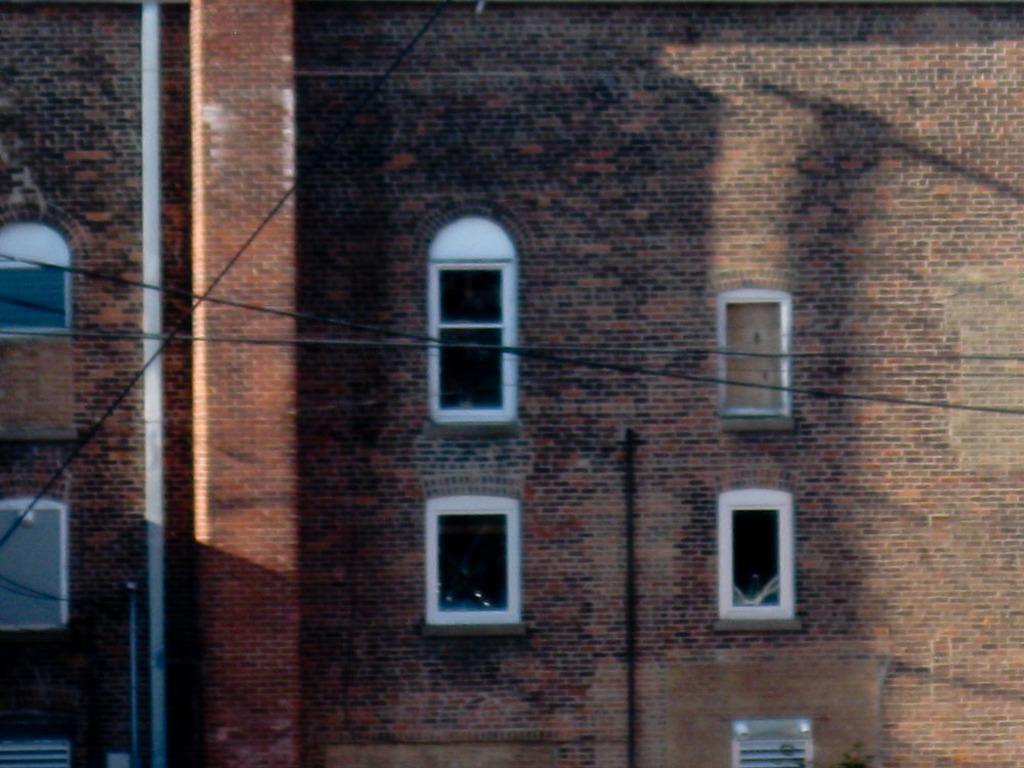What type of structure is present in the image? There is a building in the image. What feature of the building can be seen? The building has windows. What else can be seen in the image besides the building? There is a pipe and wires visible in the image. What type of hat is the volleyball wearing in the image? There is no volleyball or hat present in the image. 